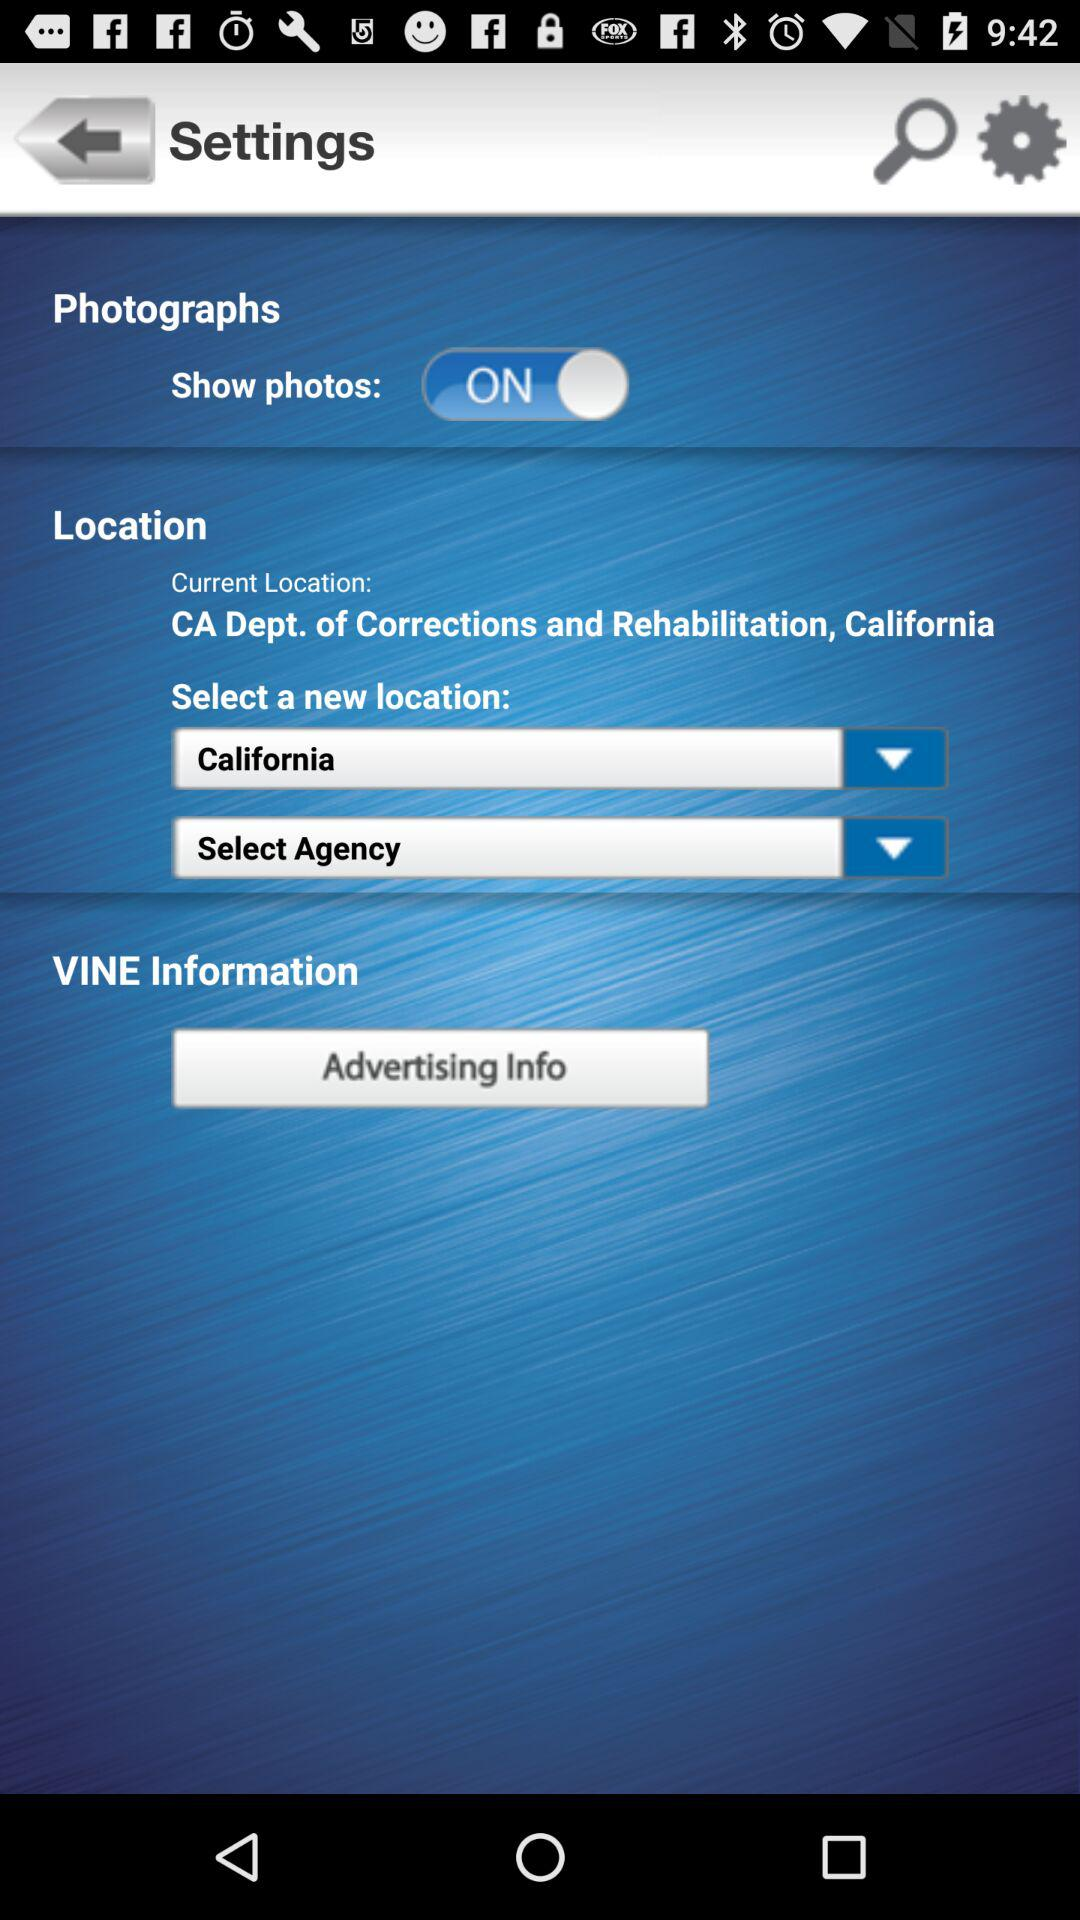What is the status of the "Show photos"? The status is "on". 